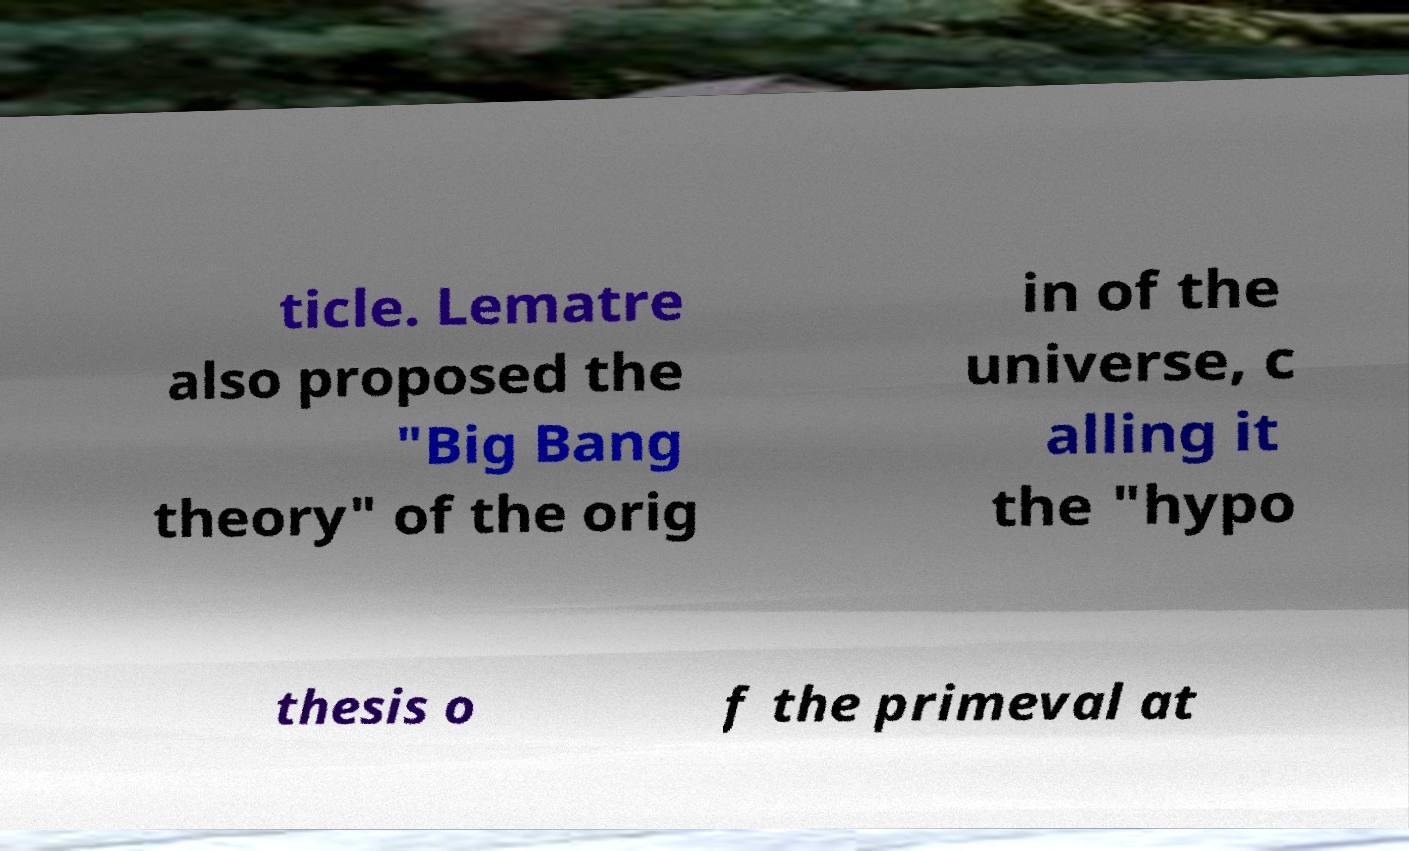What messages or text are displayed in this image? I need them in a readable, typed format. ticle. Lematre also proposed the "Big Bang theory" of the orig in of the universe, c alling it the "hypo thesis o f the primeval at 